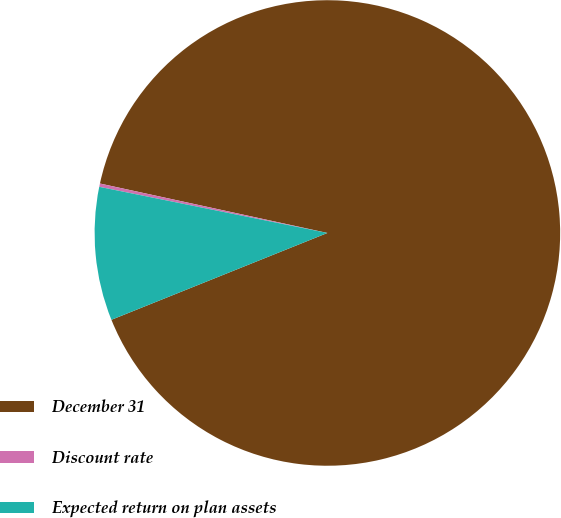Convert chart. <chart><loc_0><loc_0><loc_500><loc_500><pie_chart><fcel>December 31<fcel>Discount rate<fcel>Expected return on plan assets<nl><fcel>90.51%<fcel>0.23%<fcel>9.26%<nl></chart> 